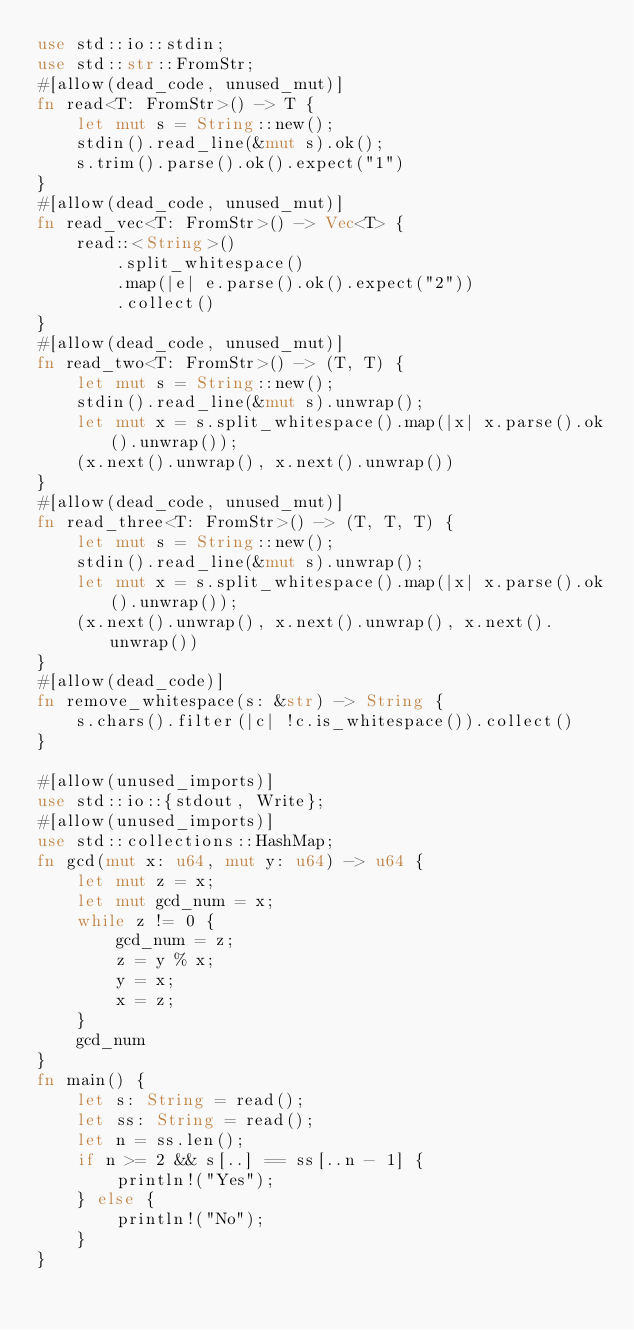<code> <loc_0><loc_0><loc_500><loc_500><_Rust_>use std::io::stdin;
use std::str::FromStr;
#[allow(dead_code, unused_mut)]
fn read<T: FromStr>() -> T {
    let mut s = String::new();
    stdin().read_line(&mut s).ok();
    s.trim().parse().ok().expect("1")
}
#[allow(dead_code, unused_mut)]
fn read_vec<T: FromStr>() -> Vec<T> {
    read::<String>()
        .split_whitespace()
        .map(|e| e.parse().ok().expect("2"))
        .collect()
}
#[allow(dead_code, unused_mut)]
fn read_two<T: FromStr>() -> (T, T) {
    let mut s = String::new();
    stdin().read_line(&mut s).unwrap();
    let mut x = s.split_whitespace().map(|x| x.parse().ok().unwrap());
    (x.next().unwrap(), x.next().unwrap())
}
#[allow(dead_code, unused_mut)]
fn read_three<T: FromStr>() -> (T, T, T) {
    let mut s = String::new();
    stdin().read_line(&mut s).unwrap();
    let mut x = s.split_whitespace().map(|x| x.parse().ok().unwrap());
    (x.next().unwrap(), x.next().unwrap(), x.next().unwrap())
}
#[allow(dead_code)]
fn remove_whitespace(s: &str) -> String {
    s.chars().filter(|c| !c.is_whitespace()).collect()
}

#[allow(unused_imports)]
use std::io::{stdout, Write};
#[allow(unused_imports)]
use std::collections::HashMap;
fn gcd(mut x: u64, mut y: u64) -> u64 {
    let mut z = x;
    let mut gcd_num = x;
    while z != 0 {
        gcd_num = z;
        z = y % x;
        y = x;
        x = z;
    }
    gcd_num
}
fn main() {
    let s: String = read();
    let ss: String = read();
    let n = ss.len();
    if n >= 2 && s[..] == ss[..n - 1] {
        println!("Yes");
    } else {
        println!("No");
    }
}
</code> 